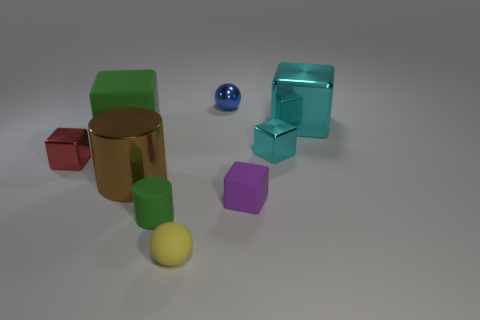How many cyan cubes must be subtracted to get 1 cyan cubes? 1 Subtract 1 blocks. How many blocks are left? 4 Subtract all red cubes. How many cubes are left? 4 Subtract all yellow cubes. Subtract all brown spheres. How many cubes are left? 5 Add 1 tiny blue shiny objects. How many objects exist? 10 Subtract all cylinders. How many objects are left? 7 Add 8 tiny blue rubber spheres. How many tiny blue rubber spheres exist? 8 Subtract 0 gray spheres. How many objects are left? 9 Subtract all yellow cylinders. Subtract all metallic balls. How many objects are left? 8 Add 8 shiny spheres. How many shiny spheres are left? 9 